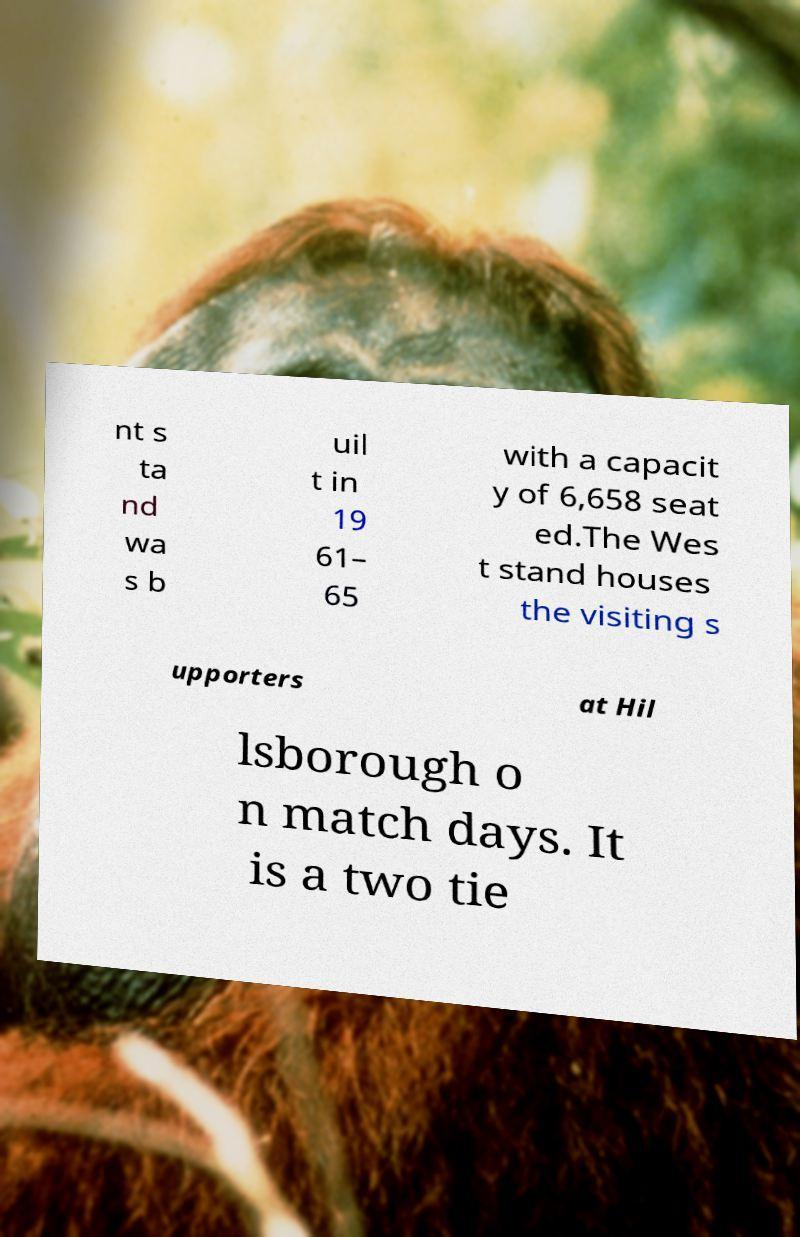Please identify and transcribe the text found in this image. nt s ta nd wa s b uil t in 19 61– 65 with a capacit y of 6,658 seat ed.The Wes t stand houses the visiting s upporters at Hil lsborough o n match days. It is a two tie 